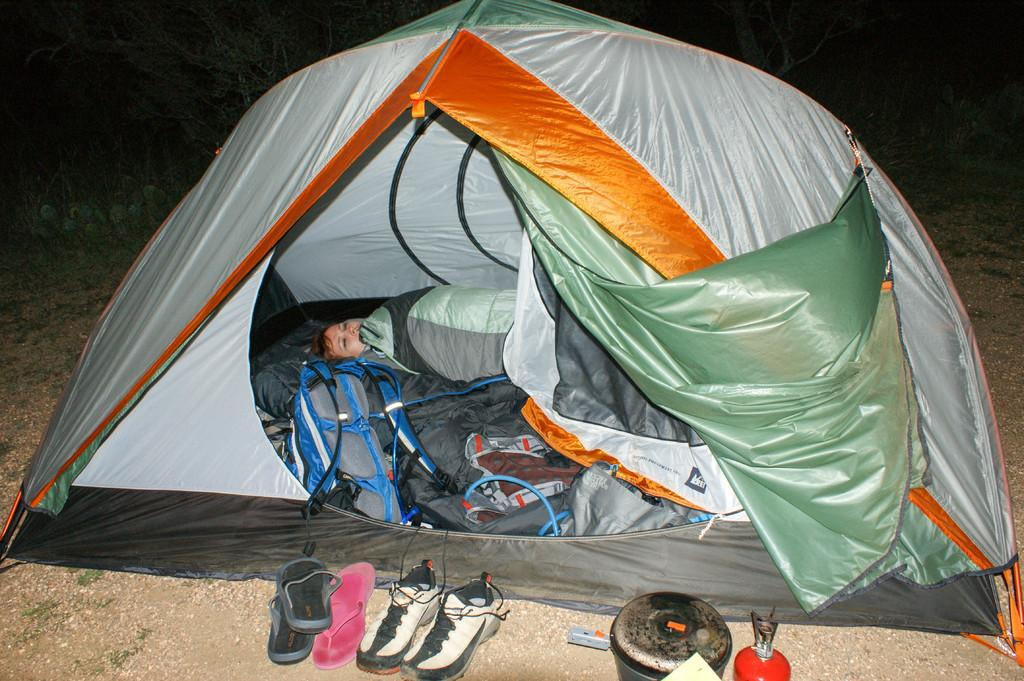What structure can be seen in the image? There is a tent in the image. Who or what is inside the tent? There is a man inside the tent. What type of footwear is visible in the image? There are shoes and slippers in the image. What object related to fuel is present in the image? There is a gas can in the image. What advice does the man's mother give him in the image? There is no mention of the man's mother or any advice in the image. What type of pan is being used to cook in the image? There is no pan or cooking activity depicted in the image. 